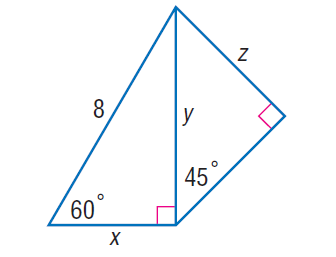Answer the mathemtical geometry problem and directly provide the correct option letter.
Question: Find x.
Choices: A: 2 \sqrt { 3 } B: 4 C: 4 \sqrt { 3 } D: 8 B 